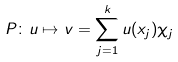Convert formula to latex. <formula><loc_0><loc_0><loc_500><loc_500>P \colon u \mapsto v = \sum _ { j = 1 } ^ { k } u ( x _ { j } ) \chi _ { j }</formula> 